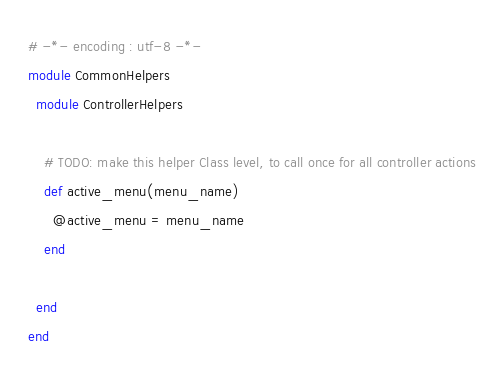Convert code to text. <code><loc_0><loc_0><loc_500><loc_500><_Ruby_># -*- encoding : utf-8 -*-
module CommonHelpers
  module ControllerHelpers

    # TODO: make this helper Class level, to call once for all controller actions
    def active_menu(menu_name)
      @active_menu = menu_name
    end

  end
end
</code> 